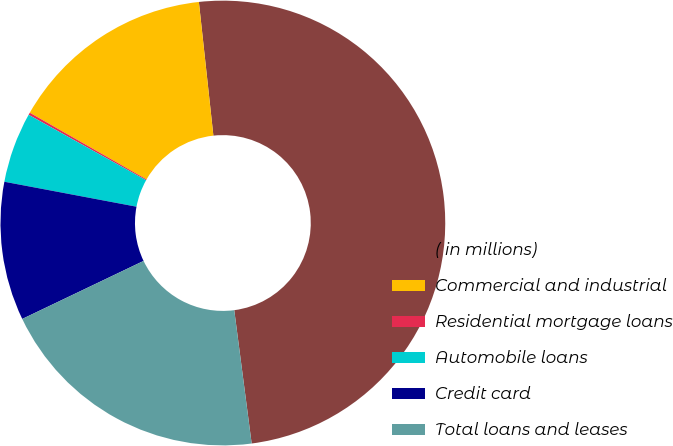Convert chart. <chart><loc_0><loc_0><loc_500><loc_500><pie_chart><fcel>( in millions)<fcel>Commercial and industrial<fcel>Residential mortgage loans<fcel>Automobile loans<fcel>Credit card<fcel>Total loans and leases<nl><fcel>49.66%<fcel>15.02%<fcel>0.17%<fcel>5.12%<fcel>10.07%<fcel>19.97%<nl></chart> 